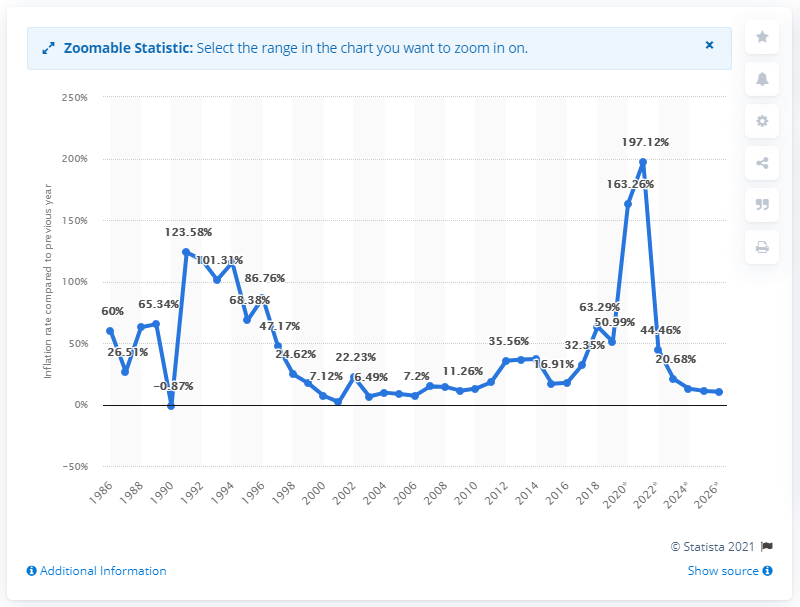Mention a couple of crucial points in this snapshot. In 2019, the inflation rate in Sudan was 50.99%. 